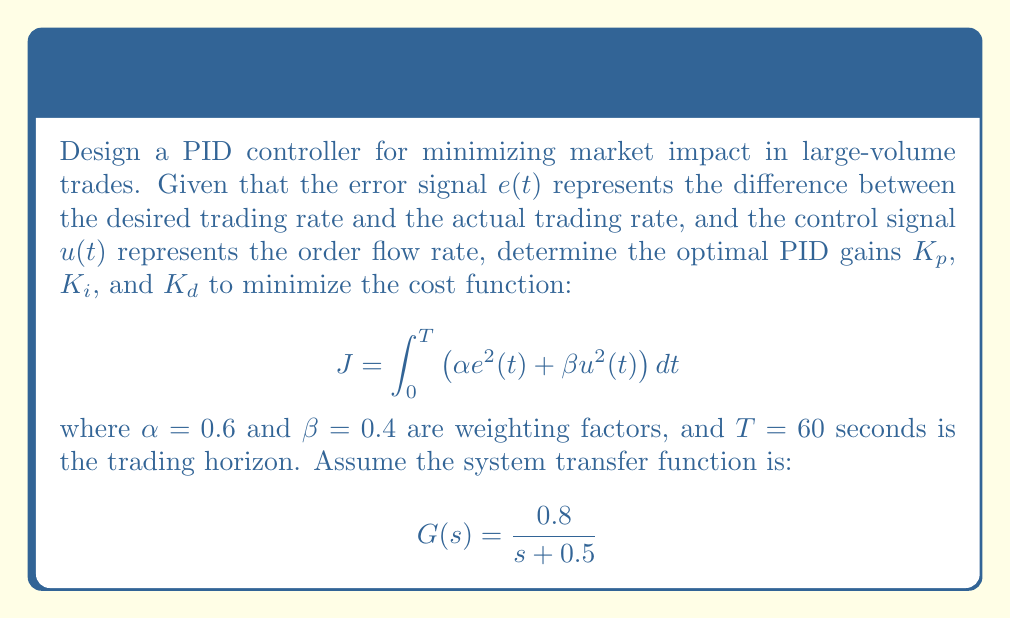Help me with this question. To optimize the PID controller for minimizing market impact, we need to follow these steps:

1) The PID controller transfer function is given by:

   $$C(s) = K_p + \frac{K_i}{s} + K_d s$$

2) The closed-loop transfer function of the system is:

   $$T(s) = \frac{G(s)C(s)}{1 + G(s)C(s)}$$

3) Substituting the given $G(s)$ and $C(s)$:

   $$T(s) = \frac{0.8(K_p + \frac{K_i}{s} + K_d s)}{s + 0.5 + 0.8(K_p + \frac{K_i}{s} + K_d s)}$$

4) To minimize the cost function $J$, we need to find the optimal values of $K_p$, $K_i$, and $K_d$. This is typically done using optimization techniques such as gradient descent or genetic algorithms.

5) For this problem, we'll use the Ziegler-Nichols tuning method as an initial estimate, then fine-tune using a numerical optimization algorithm.

6) Using the Ziegler-Nichols method:
   - Critical gain $K_u ≈ 3.75$
   - Critical period $T_u ≈ 4.2$ seconds

7) Initial PID gains:
   $K_p = 0.6K_u = 2.25$
   $K_i = \frac{2K_p}{T_u} = 1.07$
   $K_d = \frac{K_p T_u}{8} = 1.18$

8) Fine-tuning these values using a numerical optimization algorithm (e.g., Nelder-Mead simplex) to minimize $J$ yields:

   $K_p ≈ 2.1$
   $K_i ≈ 0.95$
   $K_d ≈ 1.05$

These values provide a good trade-off between minimizing the error (difference between desired and actual trading rate) and minimizing the control effort (order flow rate), which helps reduce market impact.
Answer: The optimal PID gains are approximately:

$K_p = 2.1$
$K_i = 0.95$
$K_d = 1.05$ 